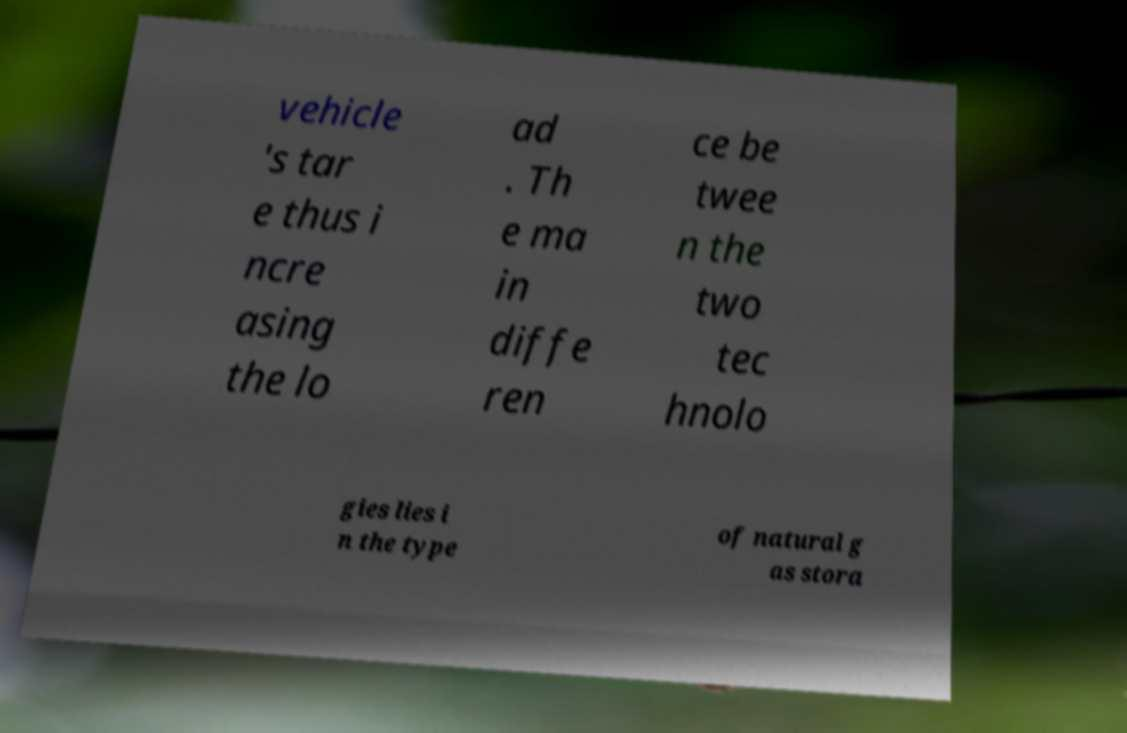Could you extract and type out the text from this image? vehicle 's tar e thus i ncre asing the lo ad . Th e ma in diffe ren ce be twee n the two tec hnolo gies lies i n the type of natural g as stora 